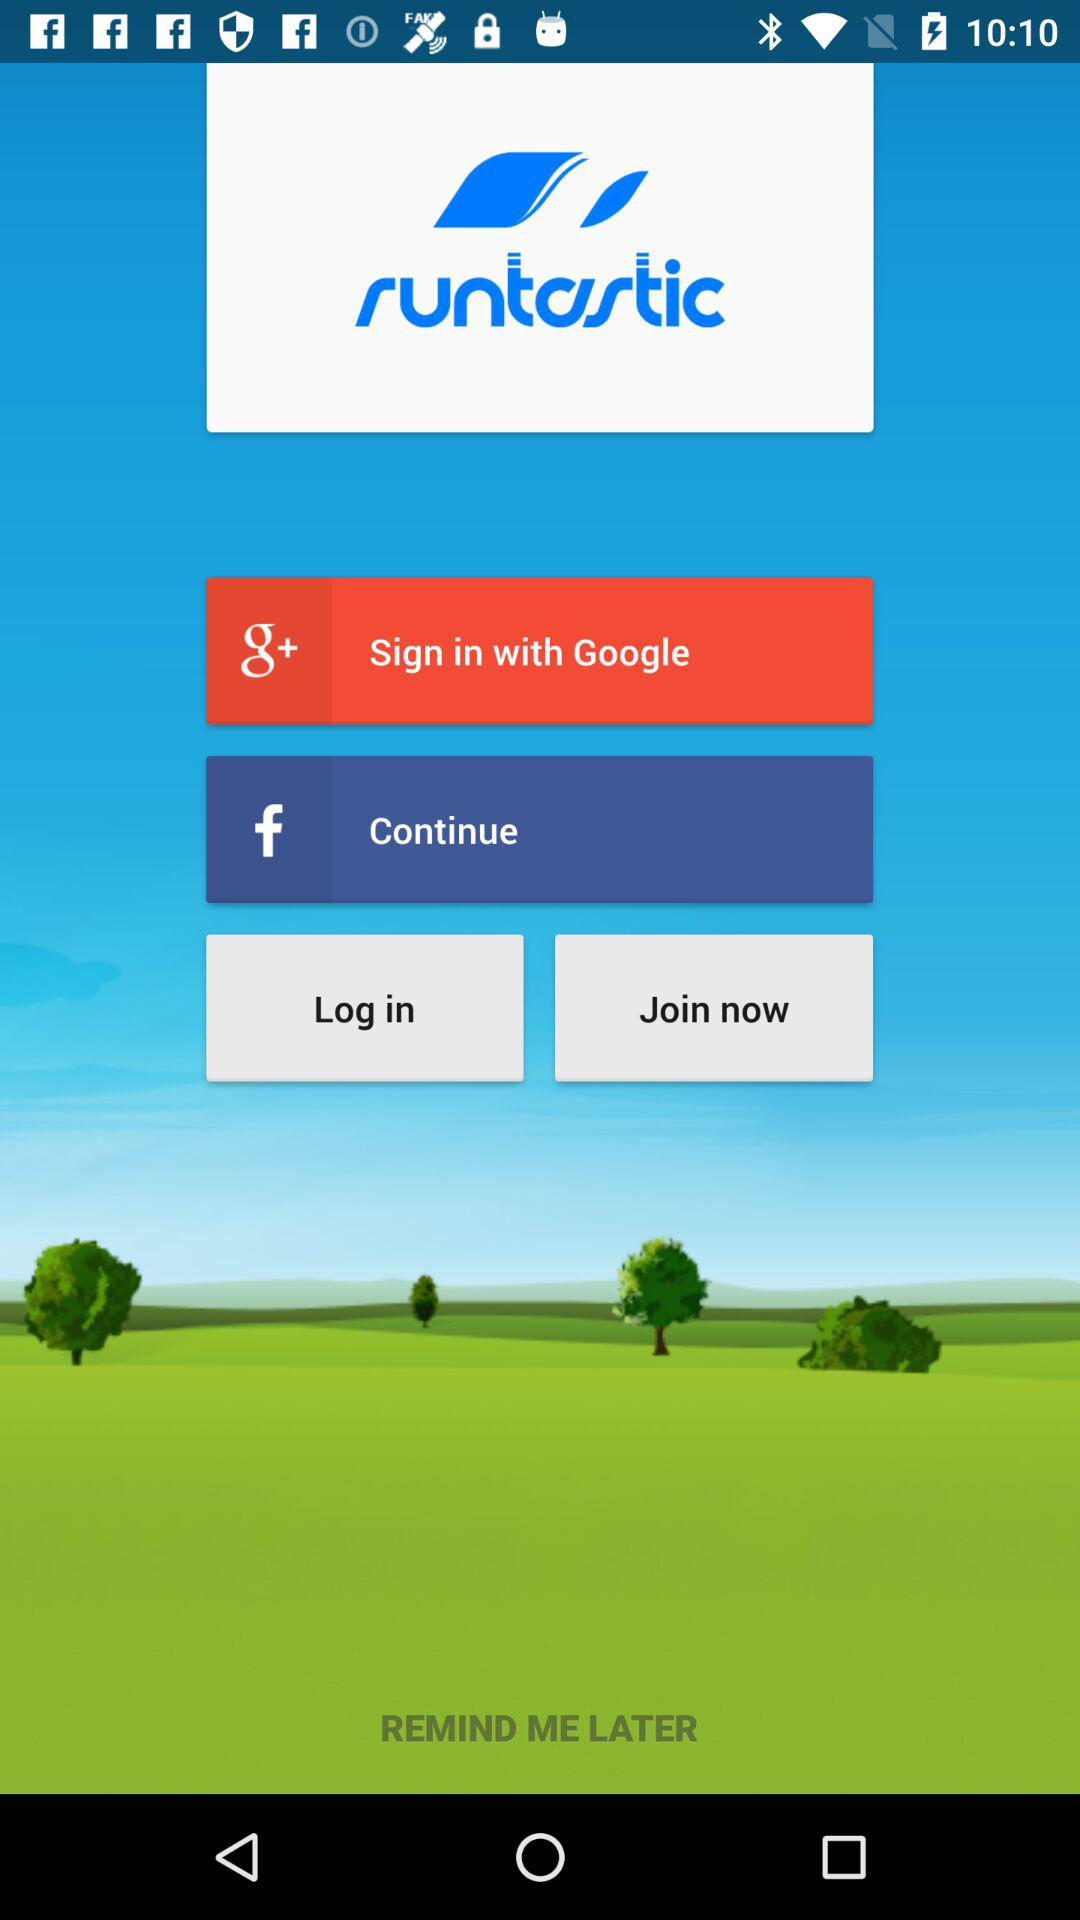What are the sign in options? You can sign in with "Google+" and "Facebook". 